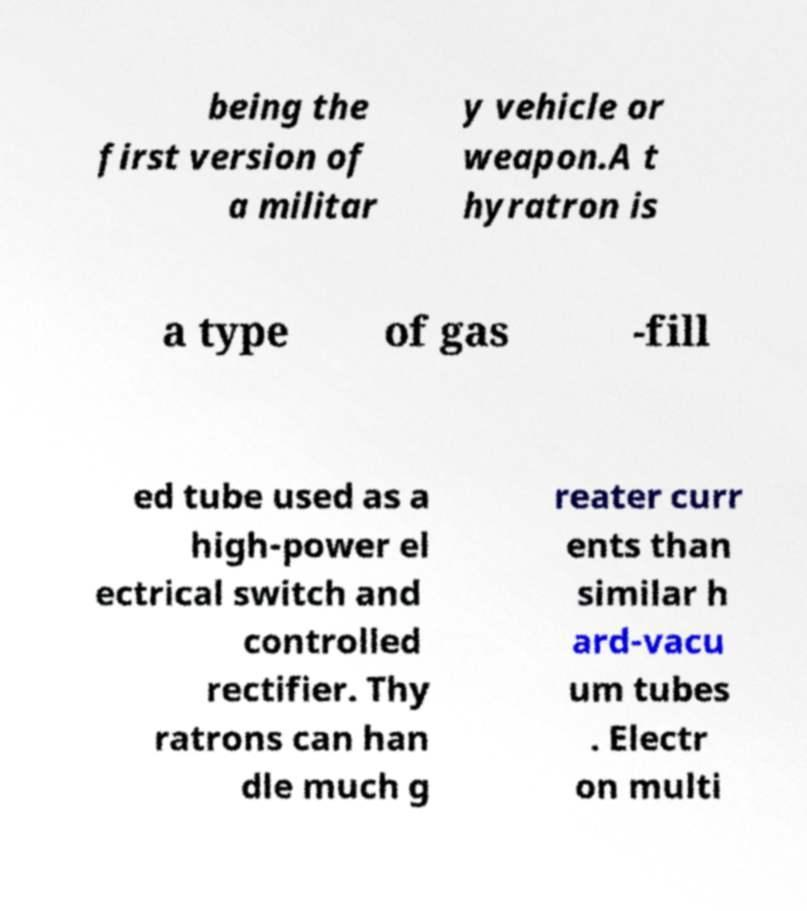Could you assist in decoding the text presented in this image and type it out clearly? being the first version of a militar y vehicle or weapon.A t hyratron is a type of gas -fill ed tube used as a high-power el ectrical switch and controlled rectifier. Thy ratrons can han dle much g reater curr ents than similar h ard-vacu um tubes . Electr on multi 